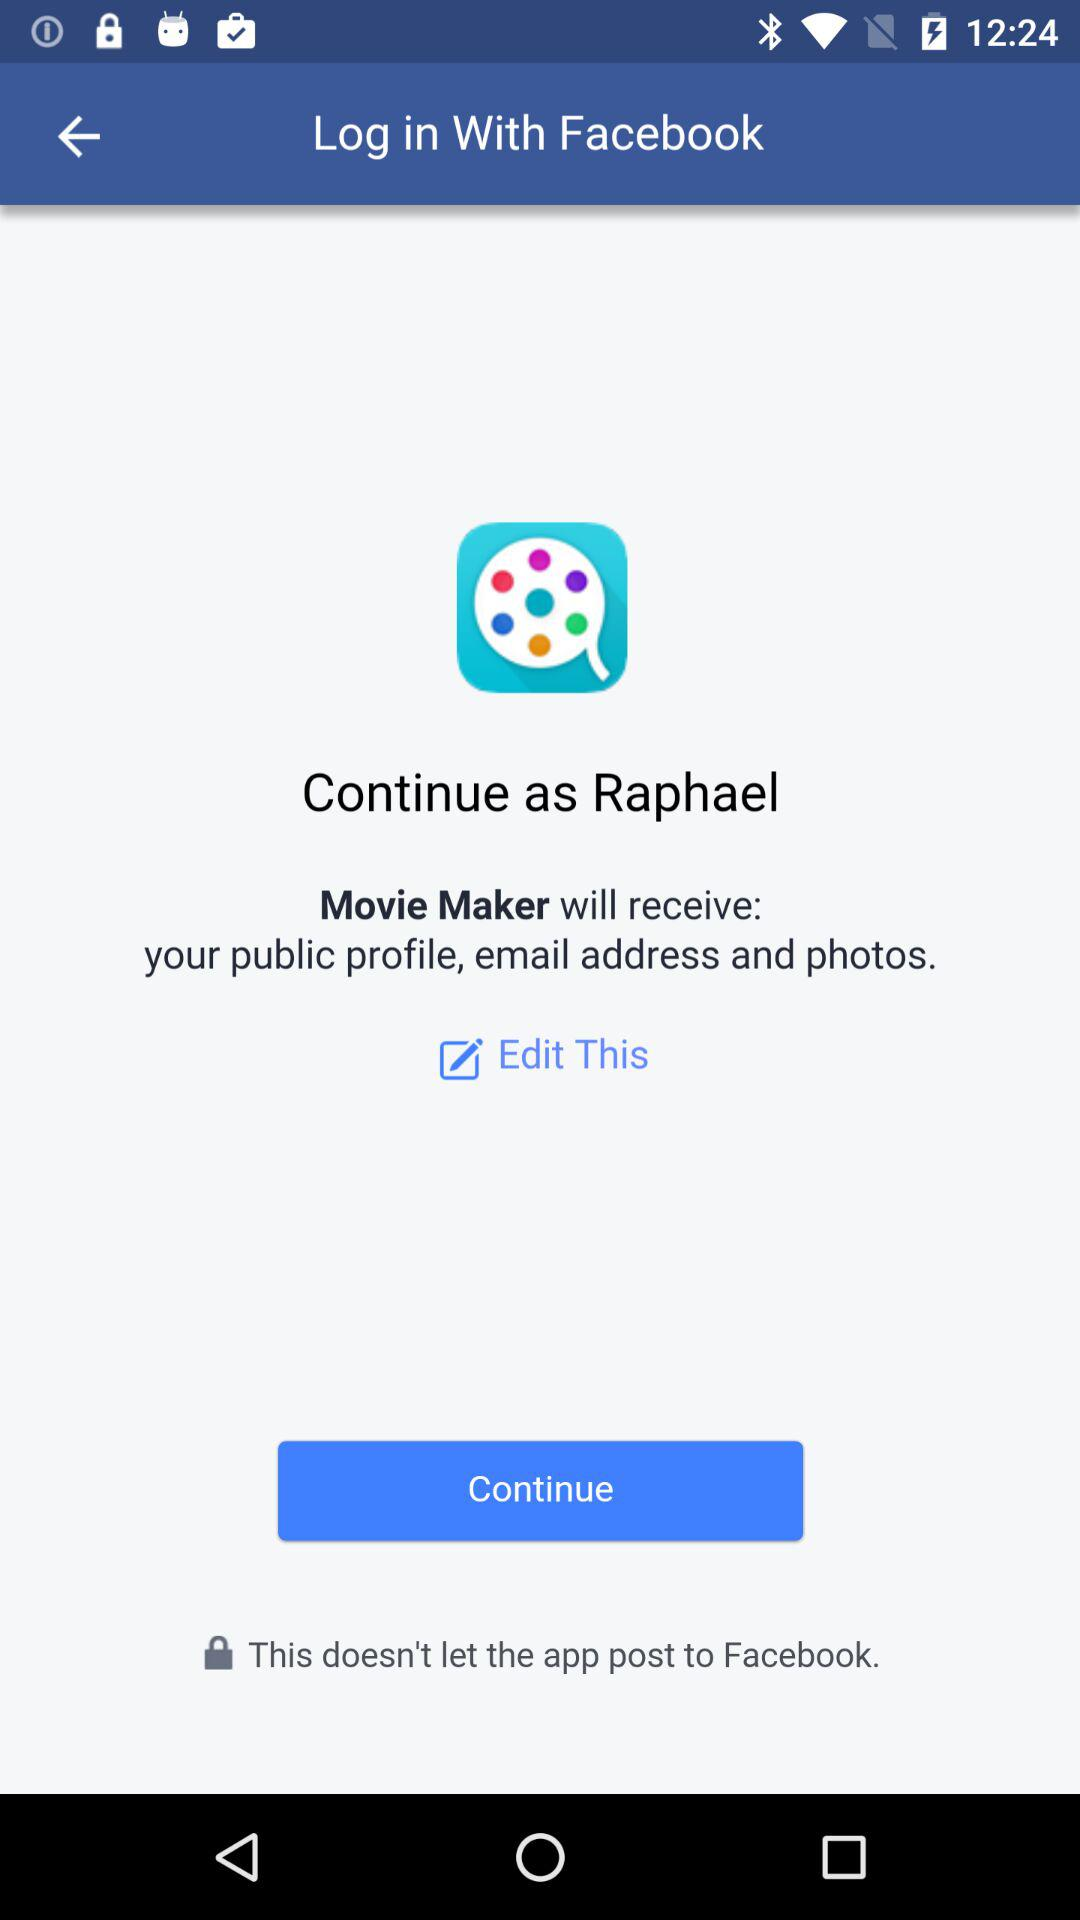What is the user name to continue on the login page? The user name is Raphael. 